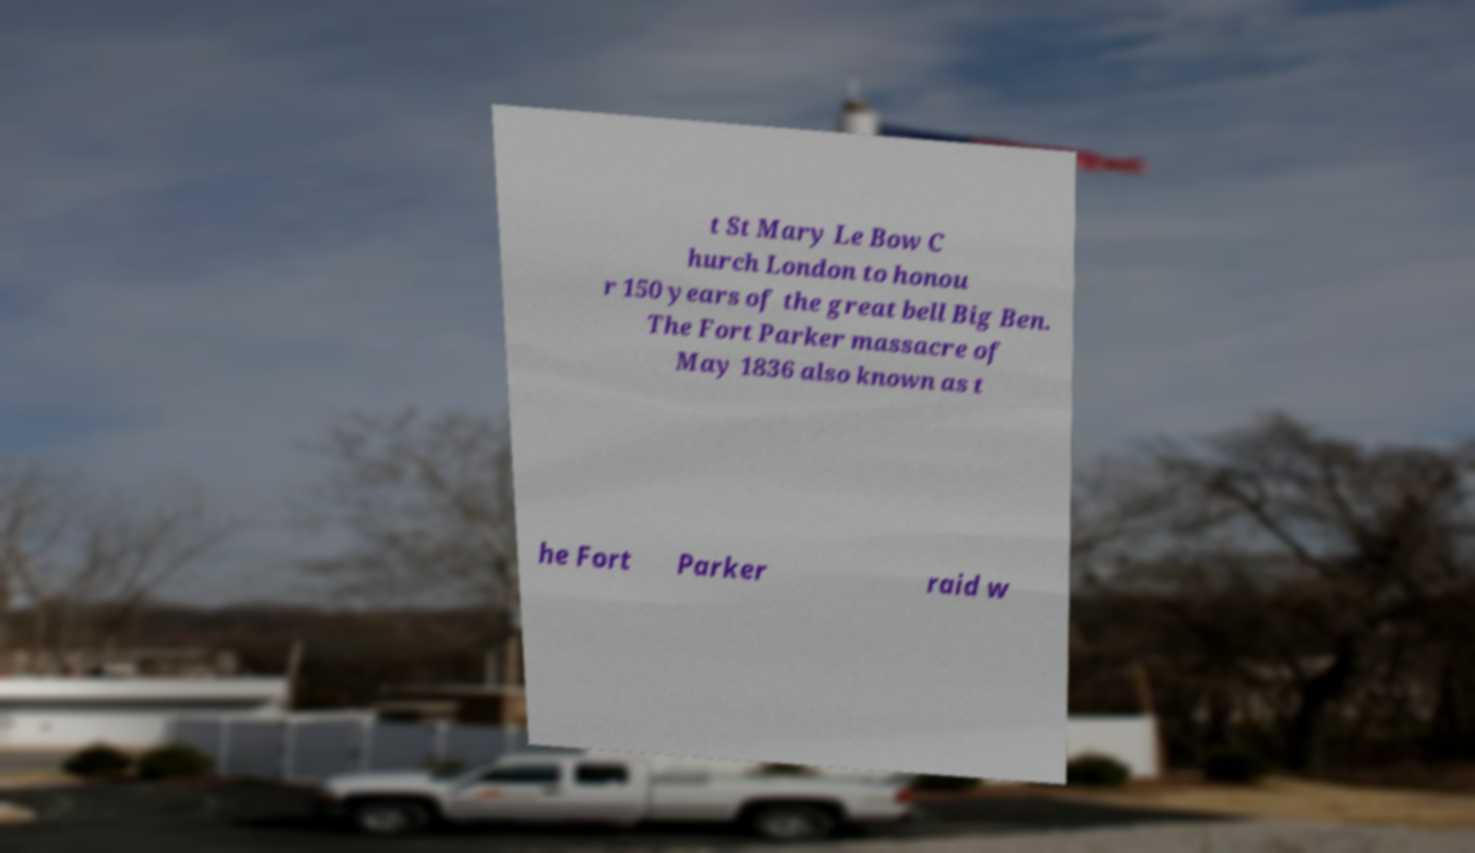Please identify and transcribe the text found in this image. t St Mary Le Bow C hurch London to honou r 150 years of the great bell Big Ben. The Fort Parker massacre of May 1836 also known as t he Fort Parker raid w 